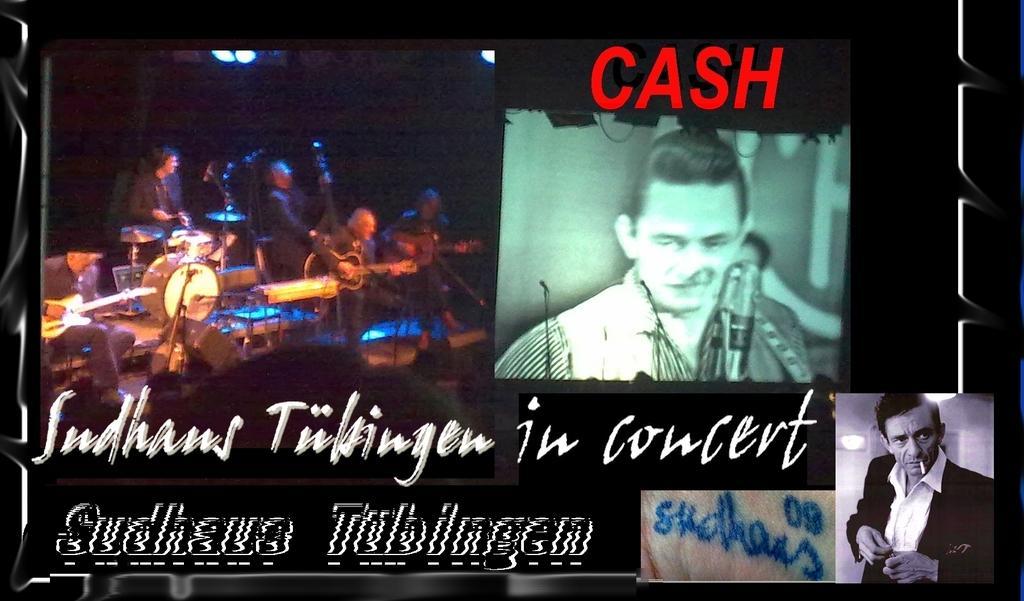Could you give a brief overview of what you see in this image? As we can see in the image there is a banner. On banner there are musical drums, mic and few people here and there. 